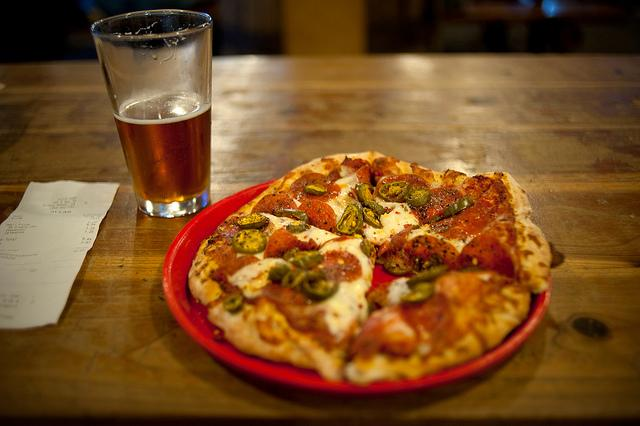What are the green items on top of the pizza? jalapenos 